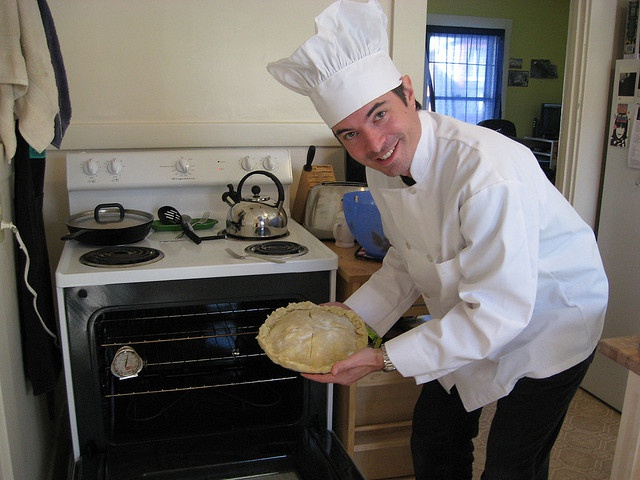Describe the objects in this image and their specific colors. I can see oven in gray, black, and darkgray tones, people in gray, darkgray, lightgray, and black tones, refrigerator in gray and black tones, bowl in gray, darkblue, navy, and black tones, and tv in gray, black, darkblue, navy, and blue tones in this image. 